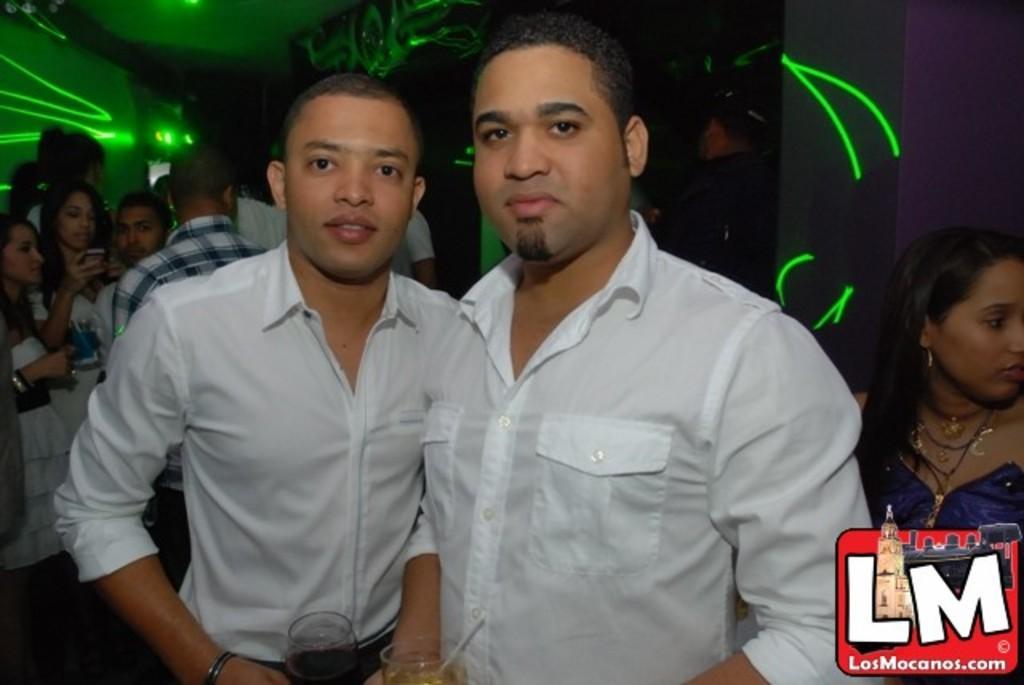In one or two sentences, can you explain what this image depicts? In this picture I can see two persons holding glasses, there are group of people standing, and in the background there is a wall and there is a watermark on the image. 